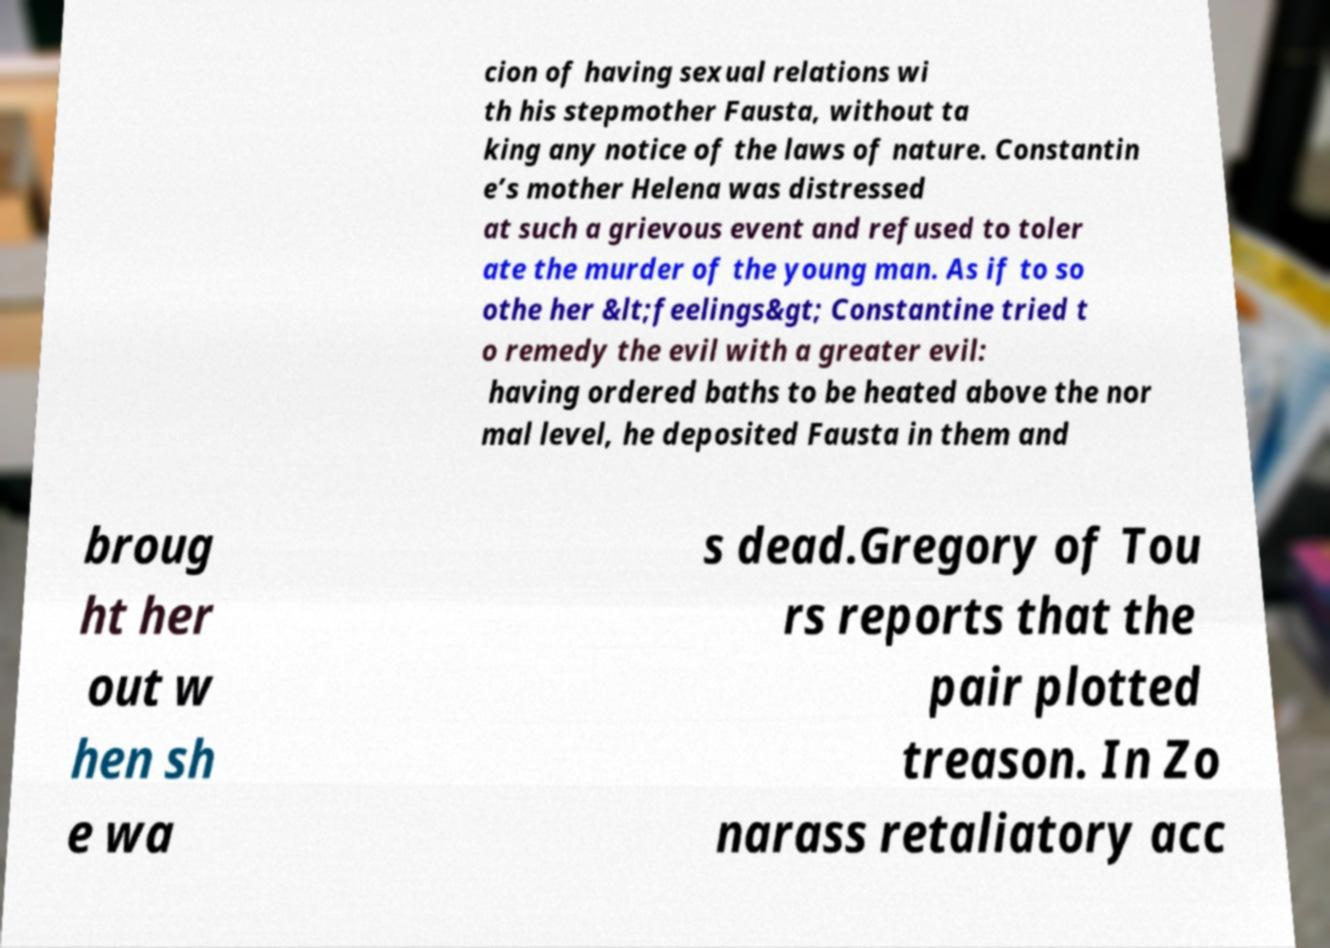Can you accurately transcribe the text from the provided image for me? cion of having sexual relations wi th his stepmother Fausta, without ta king any notice of the laws of nature. Constantin e’s mother Helena was distressed at such a grievous event and refused to toler ate the murder of the young man. As if to so othe her &lt;feelings&gt; Constantine tried t o remedy the evil with a greater evil: having ordered baths to be heated above the nor mal level, he deposited Fausta in them and broug ht her out w hen sh e wa s dead.Gregory of Tou rs reports that the pair plotted treason. In Zo narass retaliatory acc 